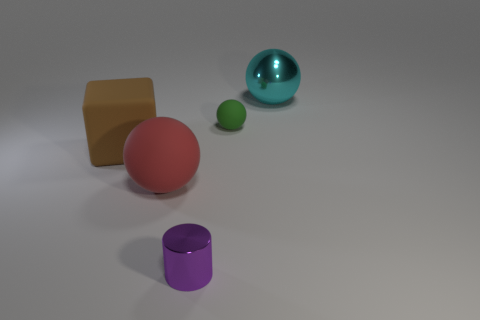Which object seems to have the roughest texture? The object with the roughest texture appears to be the brown cube. Unlike the shiny sphere and the glossy cylinder, the cube's surface has a matte finish, indicating a coarse or textured material, which would likely be rough to the touch. 